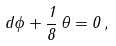Convert formula to latex. <formula><loc_0><loc_0><loc_500><loc_500>d \phi + \frac { 1 } { 8 } \, \theta = 0 \, ,</formula> 